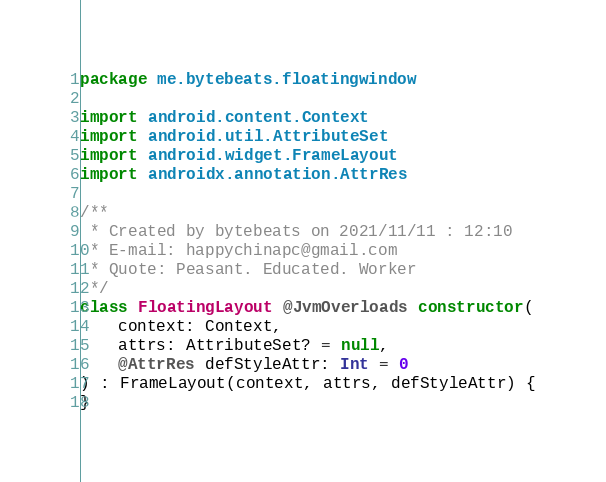Convert code to text. <code><loc_0><loc_0><loc_500><loc_500><_Kotlin_>package me.bytebeats.floatingwindow

import android.content.Context
import android.util.AttributeSet
import android.widget.FrameLayout
import androidx.annotation.AttrRes

/**
 * Created by bytebeats on 2021/11/11 : 12:10
 * E-mail: happychinapc@gmail.com
 * Quote: Peasant. Educated. Worker
 */
class FloatingLayout @JvmOverloads constructor(
    context: Context,
    attrs: AttributeSet? = null,
    @AttrRes defStyleAttr: Int = 0
) : FrameLayout(context, attrs, defStyleAttr) {
}</code> 